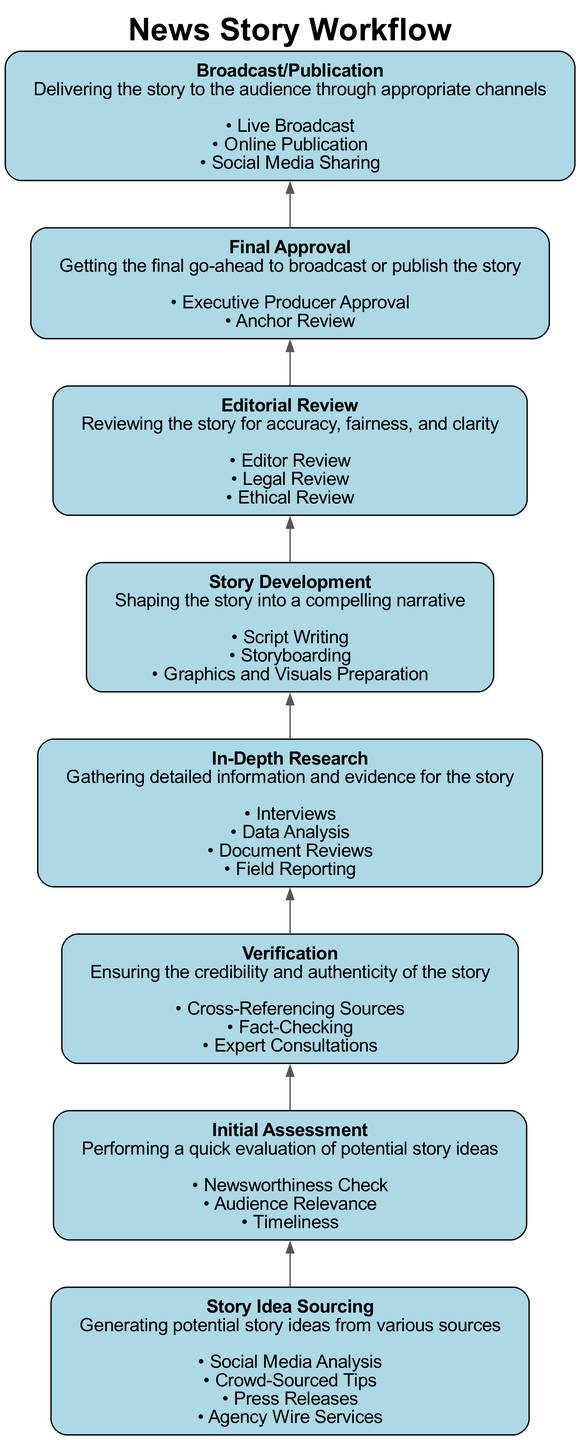What is the first step in the workflow? The first step in the workflow, as indicated at the bottom of the diagram, is "Story Idea Sourcing."
Answer: Story Idea Sourcing How many nodes are in the workflow? The workflow contains eight distinct nodes that represent different stages in the news story process.
Answer: Eight What action is associated with "Verification"? The actions listed under "Verification" include "Cross-Referencing Sources," "Fact-Checking," and "Expert Consultations."
Answer: Cross-Referencing Sources Which step comes immediately before "Final Approval"? The step that immediately precedes "Final Approval" is "Editorial Review," which is positioned one level higher in the diagram.
Answer: Editorial Review What is the last action under "In-Depth Research"? The last action listed under "In-Depth Research" is "Field Reporting," which distinctly represents gathering information in real-world contexts.
Answer: Field Reporting Identify a connection between "Story Development" and the "Broadcast/Publication" step. "Story Development" is a preceding step to "Broadcast/Publication," indicating that a completed story must be developed before it can be published or broadcasted.
Answer: Story Development How many actions are listed under "Initial Assessment"? There are three actions specified under "Initial Assessment," which evaluate the viability of story ideas.
Answer: Three What is the primary purpose of the "Editorial Review" stage? The primary purpose of "Editorial Review" is to ensure accuracy, fairness, and clarity in the story before publication or broadcast.
Answer: Accuracy, fairness, and clarity Which stage includes "Script Writing" as an action? The stage that includes "Script Writing" as an action is "Story Development," where the narrative of the story is formed.
Answer: Story Development 